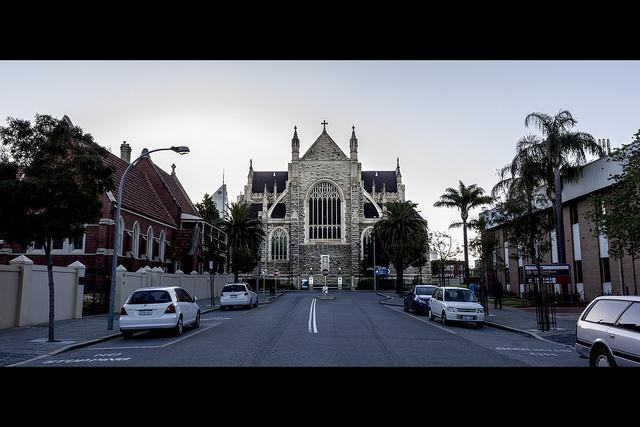How many vehicles are in this image?
Give a very brief answer. 5. How many busses are in this picture?
Give a very brief answer. 0. How many cars can you see?
Give a very brief answer. 2. 